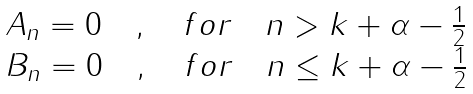<formula> <loc_0><loc_0><loc_500><loc_500>\begin{array} { c } { { A _ { n } = 0 \quad , \quad f o r \quad n > k + \alpha - \frac { 1 } { 2 } } } \\ { { B _ { n } = 0 \quad , \quad f o r \quad n \leq k + \alpha - \frac { 1 } { 2 } } } \end{array}</formula> 